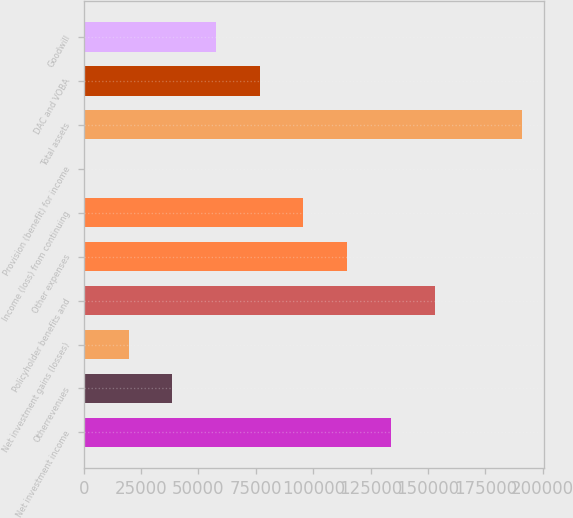Convert chart to OTSL. <chart><loc_0><loc_0><loc_500><loc_500><bar_chart><fcel>Net investment income<fcel>Otherrevenues<fcel>Net investment gains (losses)<fcel>Policyholder benefits and<fcel>Other expenses<fcel>Income (loss) from continuing<fcel>Provision (benefit) for income<fcel>Total assets<fcel>DAC and VOBA<fcel>Goodwill<nl><fcel>133843<fcel>38643<fcel>19603<fcel>152883<fcel>114803<fcel>95763<fcel>563<fcel>190963<fcel>76723<fcel>57683<nl></chart> 